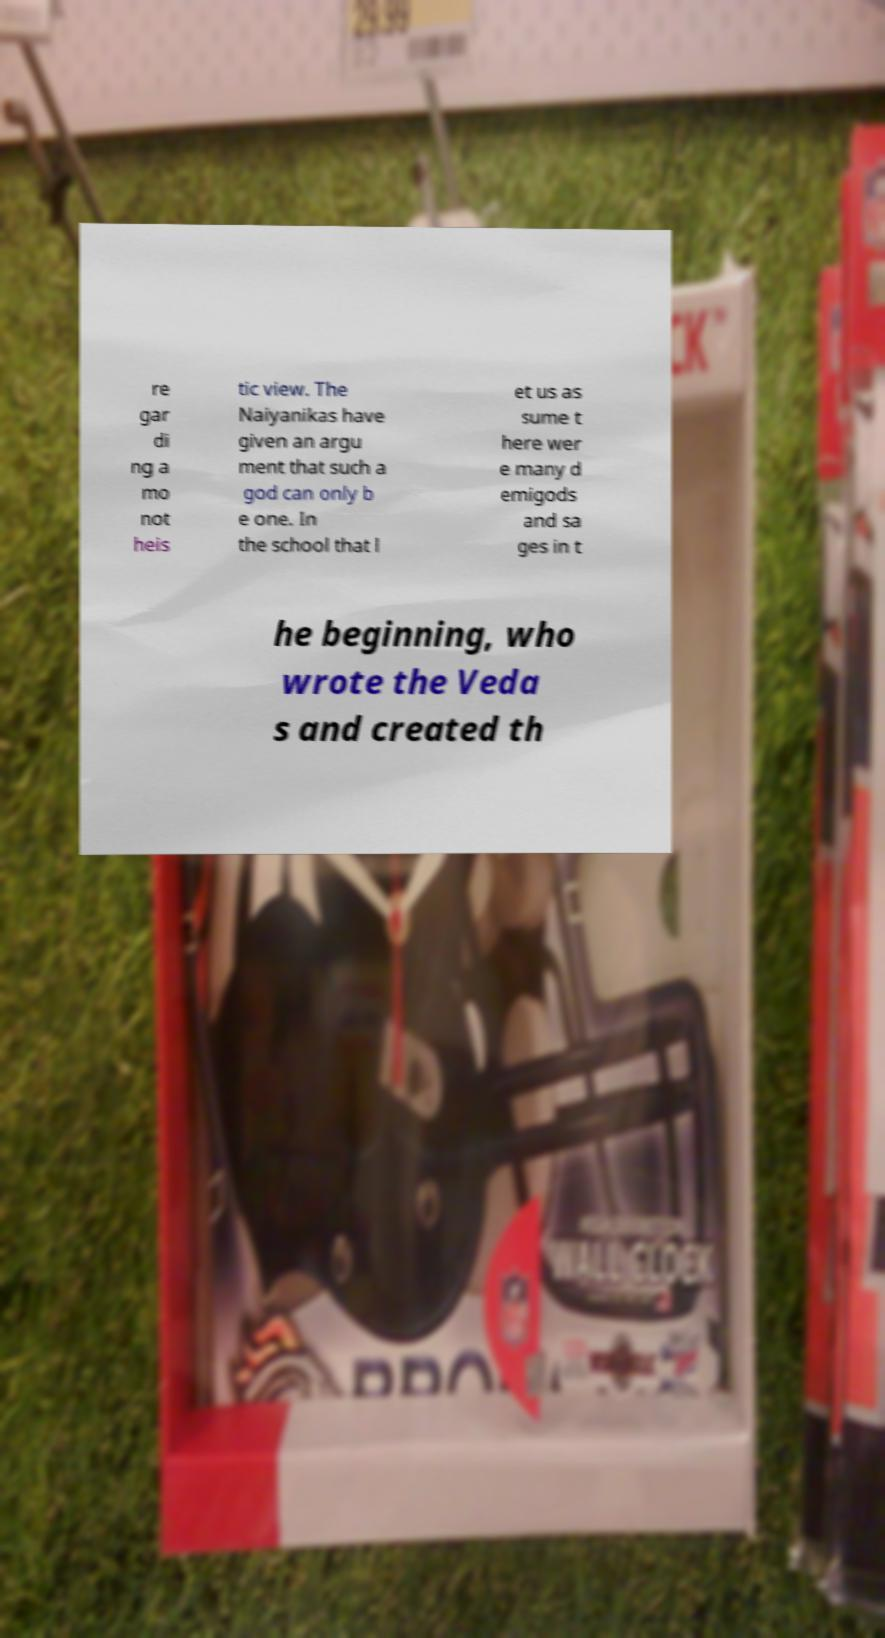Please identify and transcribe the text found in this image. re gar di ng a mo not heis tic view. The Naiyanikas have given an argu ment that such a god can only b e one. In the school that l et us as sume t here wer e many d emigods and sa ges in t he beginning, who wrote the Veda s and created th 